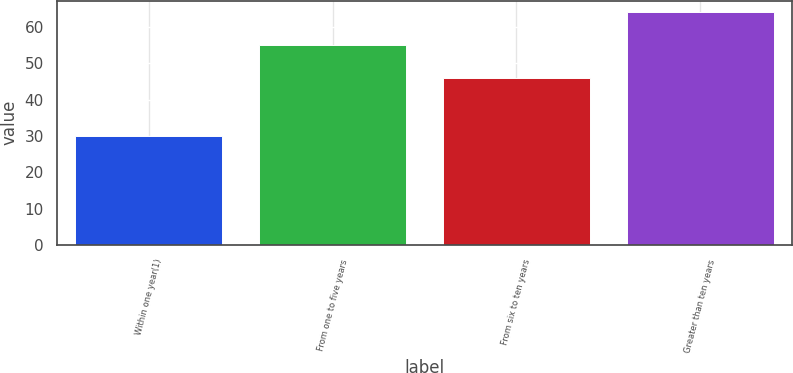Convert chart to OTSL. <chart><loc_0><loc_0><loc_500><loc_500><bar_chart><fcel>Within one year(1)<fcel>From one to five years<fcel>From six to ten years<fcel>Greater than ten years<nl><fcel>30<fcel>55<fcel>46<fcel>64<nl></chart> 